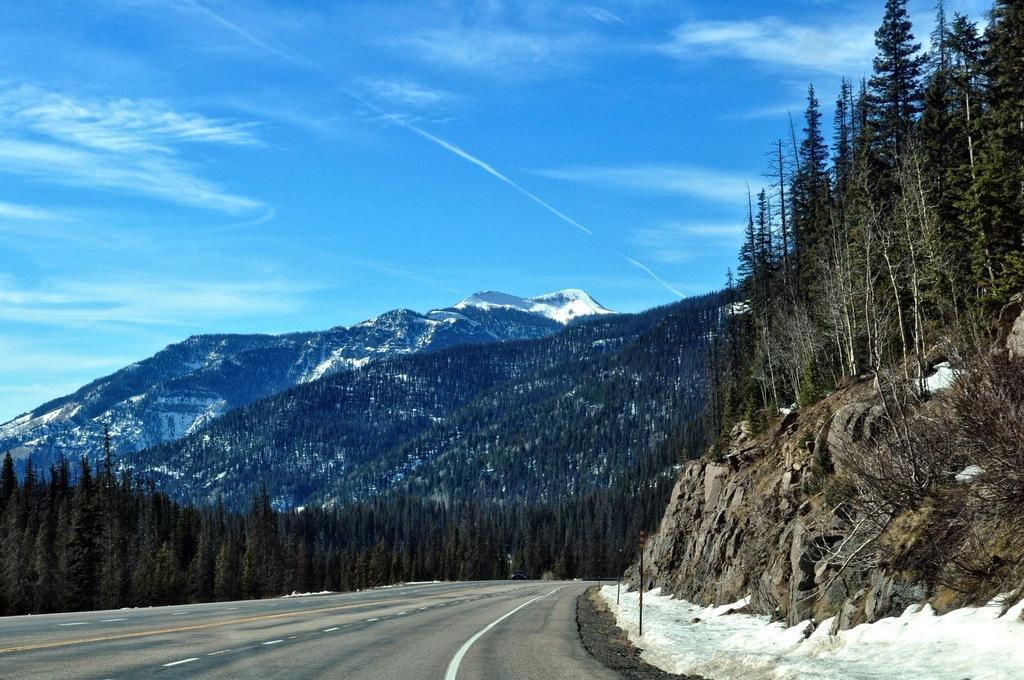How would you summarize this image in a sentence or two? This is the picture of a mountain. At the back there are mountains and there are trees. At the top there is sky and there are clouds. At the bottom there is a road and there is snow. 